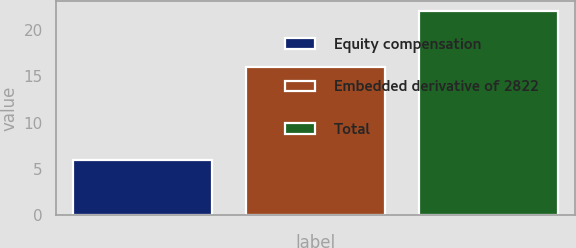<chart> <loc_0><loc_0><loc_500><loc_500><bar_chart><fcel>Equity compensation<fcel>Embedded derivative of 2822<fcel>Total<nl><fcel>6<fcel>16<fcel>22<nl></chart> 